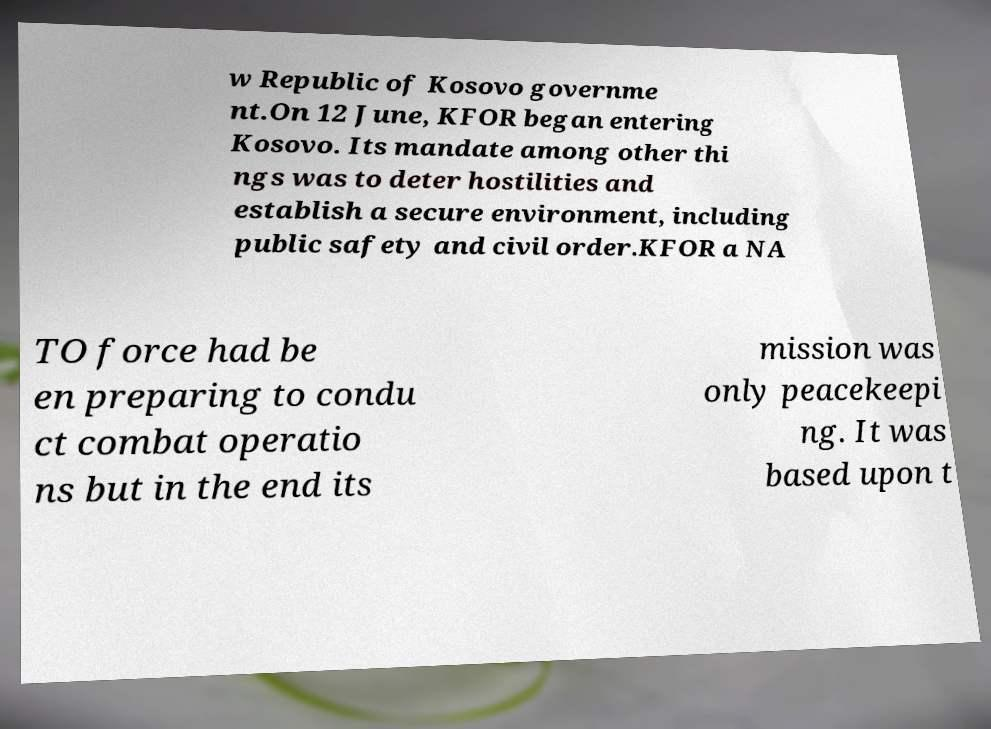I need the written content from this picture converted into text. Can you do that? w Republic of Kosovo governme nt.On 12 June, KFOR began entering Kosovo. Its mandate among other thi ngs was to deter hostilities and establish a secure environment, including public safety and civil order.KFOR a NA TO force had be en preparing to condu ct combat operatio ns but in the end its mission was only peacekeepi ng. It was based upon t 